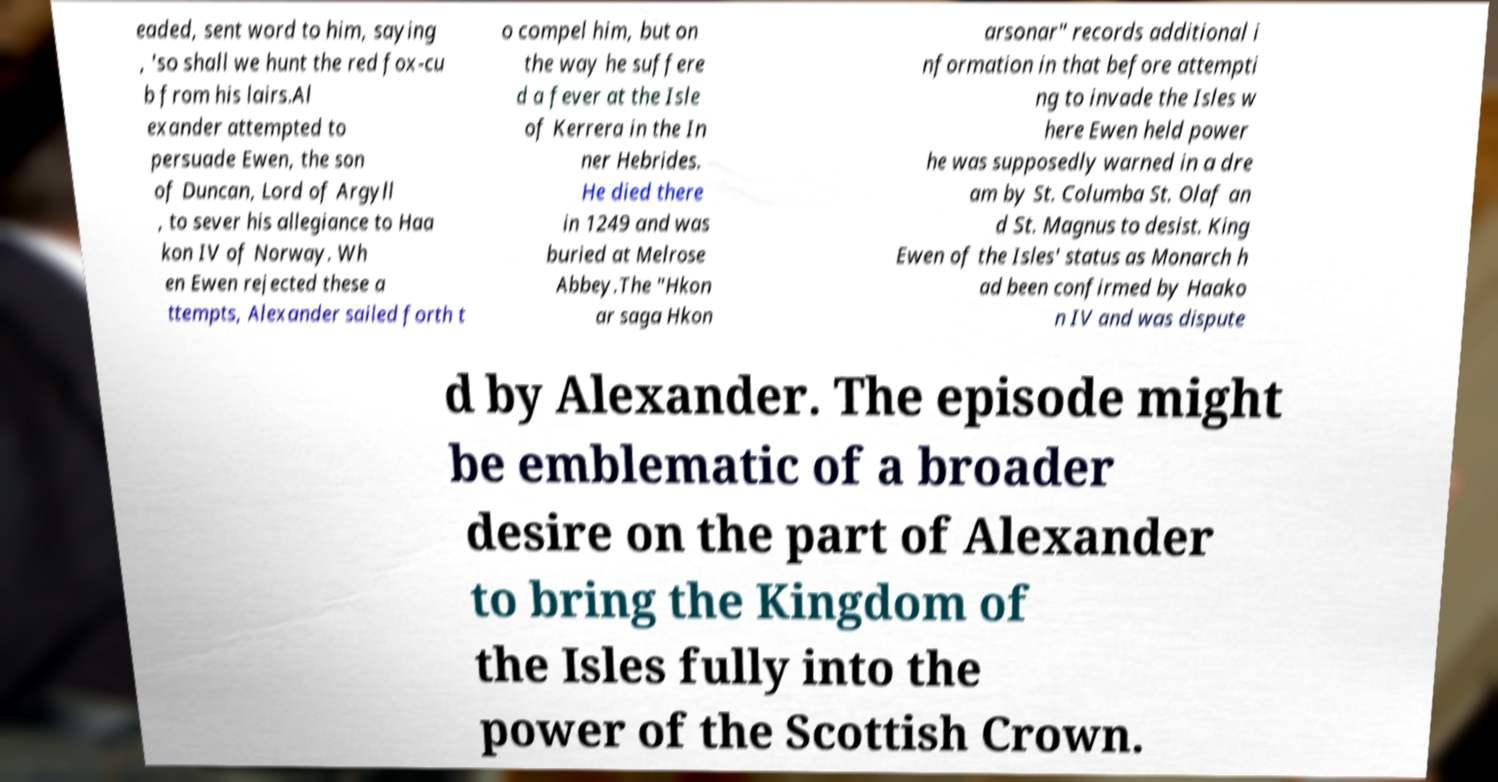Please identify and transcribe the text found in this image. eaded, sent word to him, saying , 'so shall we hunt the red fox-cu b from his lairs.Al exander attempted to persuade Ewen, the son of Duncan, Lord of Argyll , to sever his allegiance to Haa kon IV of Norway. Wh en Ewen rejected these a ttempts, Alexander sailed forth t o compel him, but on the way he suffere d a fever at the Isle of Kerrera in the In ner Hebrides. He died there in 1249 and was buried at Melrose Abbey.The "Hkon ar saga Hkon arsonar" records additional i nformation in that before attempti ng to invade the Isles w here Ewen held power he was supposedly warned in a dre am by St. Columba St. Olaf an d St. Magnus to desist. King Ewen of the Isles' status as Monarch h ad been confirmed by Haako n IV and was dispute d by Alexander. The episode might be emblematic of a broader desire on the part of Alexander to bring the Kingdom of the Isles fully into the power of the Scottish Crown. 